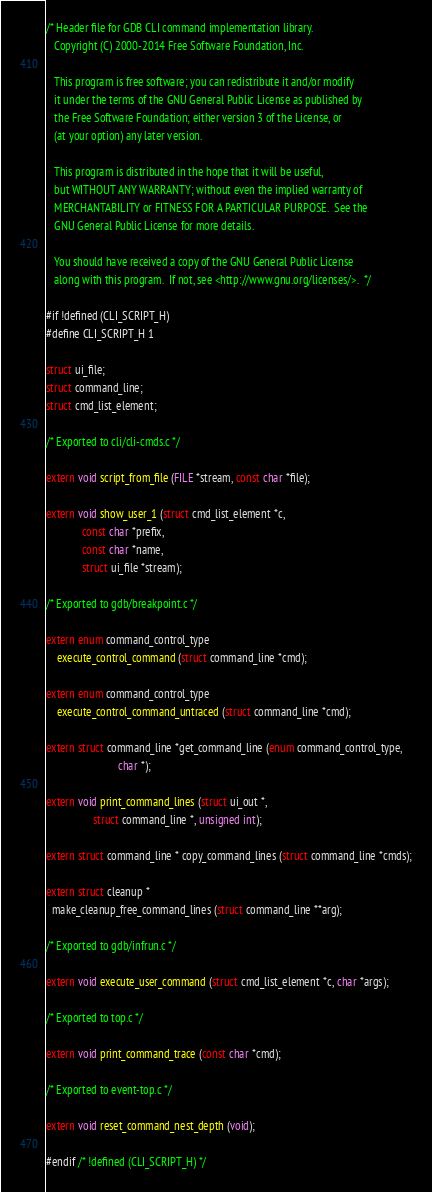Convert code to text. <code><loc_0><loc_0><loc_500><loc_500><_C_>/* Header file for GDB CLI command implementation library.
   Copyright (C) 2000-2014 Free Software Foundation, Inc.

   This program is free software; you can redistribute it and/or modify
   it under the terms of the GNU General Public License as published by
   the Free Software Foundation; either version 3 of the License, or
   (at your option) any later version.

   This program is distributed in the hope that it will be useful,
   but WITHOUT ANY WARRANTY; without even the implied warranty of
   MERCHANTABILITY or FITNESS FOR A PARTICULAR PURPOSE.  See the
   GNU General Public License for more details.

   You should have received a copy of the GNU General Public License
   along with this program.  If not, see <http://www.gnu.org/licenses/>.  */

#if !defined (CLI_SCRIPT_H)
#define CLI_SCRIPT_H 1

struct ui_file;
struct command_line;
struct cmd_list_element;

/* Exported to cli/cli-cmds.c */

extern void script_from_file (FILE *stream, const char *file);

extern void show_user_1 (struct cmd_list_element *c,
			 const char *prefix,
			 const char *name,
			 struct ui_file *stream);

/* Exported to gdb/breakpoint.c */

extern enum command_control_type
	execute_control_command (struct command_line *cmd);

extern enum command_control_type
	execute_control_command_untraced (struct command_line *cmd);

extern struct command_line *get_command_line (enum command_control_type,
					      char *);

extern void print_command_lines (struct ui_out *,
				 struct command_line *, unsigned int);

extern struct command_line * copy_command_lines (struct command_line *cmds);

extern struct cleanup *
  make_cleanup_free_command_lines (struct command_line **arg);

/* Exported to gdb/infrun.c */

extern void execute_user_command (struct cmd_list_element *c, char *args);

/* Exported to top.c */

extern void print_command_trace (const char *cmd);

/* Exported to event-top.c */

extern void reset_command_nest_depth (void);

#endif /* !defined (CLI_SCRIPT_H) */
</code> 